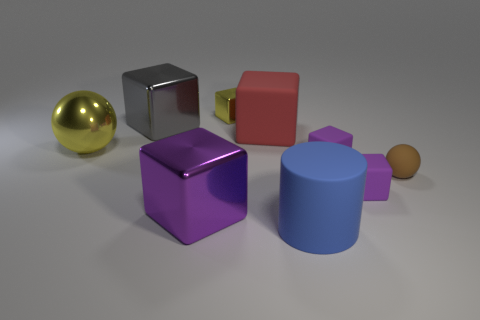Subtract all red blocks. How many blocks are left? 5 Subtract all yellow balls. How many balls are left? 1 Subtract 2 balls. How many balls are left? 0 Subtract 2 purple cubes. How many objects are left? 7 Subtract all cylinders. How many objects are left? 8 Subtract all purple cylinders. Subtract all yellow cubes. How many cylinders are left? 1 Subtract all cyan blocks. How many yellow cylinders are left? 0 Subtract all blue things. Subtract all yellow cubes. How many objects are left? 7 Add 7 red objects. How many red objects are left? 8 Add 7 small brown rubber spheres. How many small brown rubber spheres exist? 8 